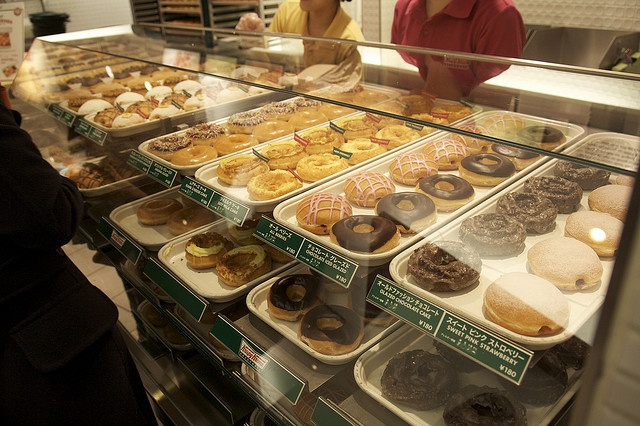Describe the objects in this image and their specific colors. I can see donut in maroon, tan, and black tones, people in maroon, black, tan, and gray tones, people in maroon and brown tones, people in maroon, brown, tan, and khaki tones, and donut in maroon, gray, and tan tones in this image. 